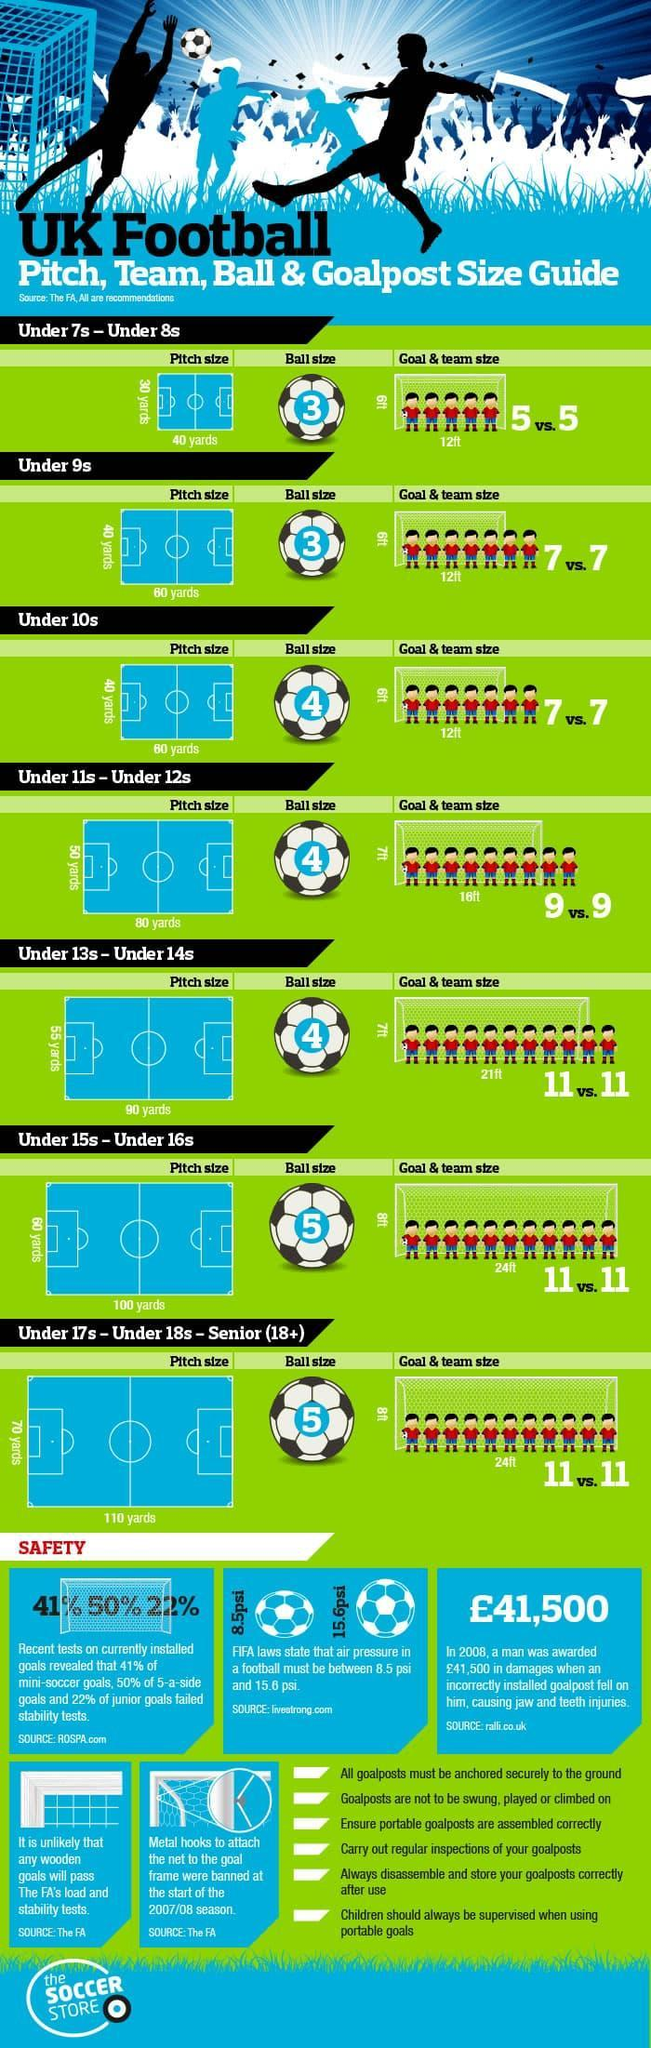What is the goal length required for a 100 yard pitch?
Answer the question with a short phrase. 24 ft Which teams use ball size 3? Under 7s - Under 8s, Under 9s What is the recommended pitch length for a team of 11? 110 yards Which team has recommended pitch size of 40 x 60 yards and ball size of 4? Under 10s Which two teams use a pitch of size 40 x 60 yards? Under 9s, Under 10s 